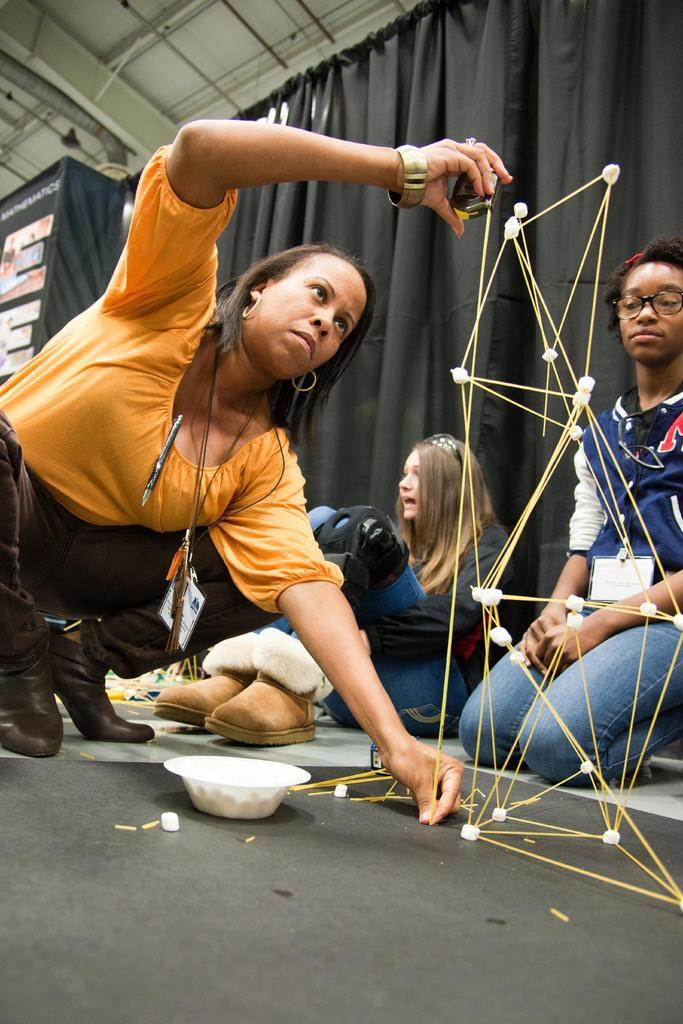Who is the main subject in the image? There is a woman in the image. What is the woman doing in the image? The woman is forming a ladder with sticks. Are there any other people present in the image? Yes, there are other people sitting and watching in the image. What can be seen hanging from the top in the image? There is a curtain hanging from the top in the image. What type of manager can be seen interacting with the bears in the image? There are no bears or managers present in the image. How many giraffes are visible in the image? There are no giraffes visible in the image. 